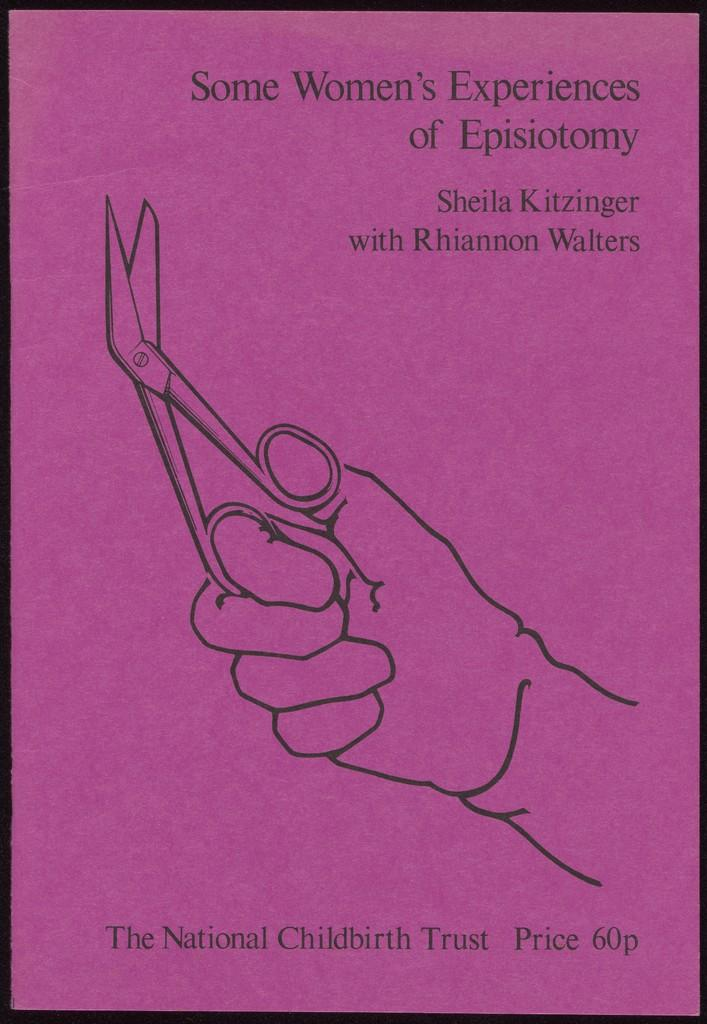<image>
Create a compact narrative representing the image presented. Pink background with a drawing of a hand holding scissors and the words "The National Childbirth Trust" on the bottom. 